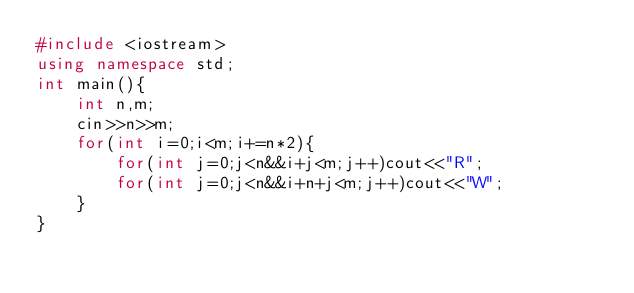Convert code to text. <code><loc_0><loc_0><loc_500><loc_500><_C++_>#include <iostream>
using namespace std;
int main(){
	int n,m;
	cin>>n>>m;
	for(int i=0;i<m;i+=n*2){
		for(int j=0;j<n&&i+j<m;j++)cout<<"R";
		for(int j=0;j<n&&i+n+j<m;j++)cout<<"W";
	}
}
</code> 